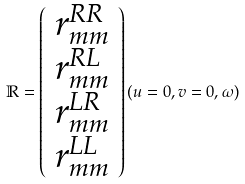Convert formula to latex. <formula><loc_0><loc_0><loc_500><loc_500>\mathbb { R } = \left ( \begin{array} { c } r ^ { R R } _ { m m } \\ r ^ { R L } _ { m m } \\ r ^ { L R } _ { m m } \\ r ^ { L L } _ { m m } \\ \end{array} \right ) ( u = 0 , v = 0 , \omega )</formula> 